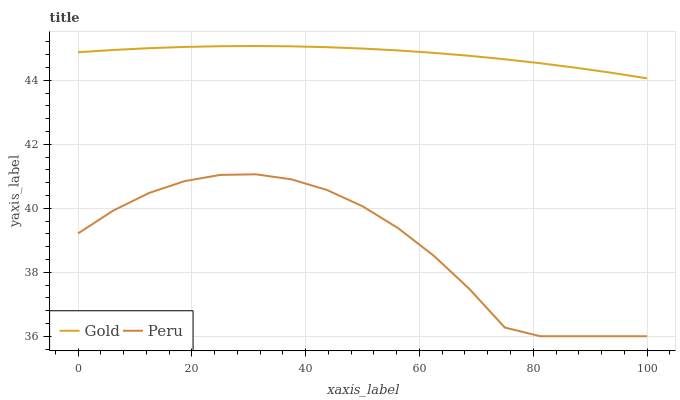Does Gold have the minimum area under the curve?
Answer yes or no. No. Is Gold the roughest?
Answer yes or no. No. Does Gold have the lowest value?
Answer yes or no. No. Is Peru less than Gold?
Answer yes or no. Yes. Is Gold greater than Peru?
Answer yes or no. Yes. Does Peru intersect Gold?
Answer yes or no. No. 